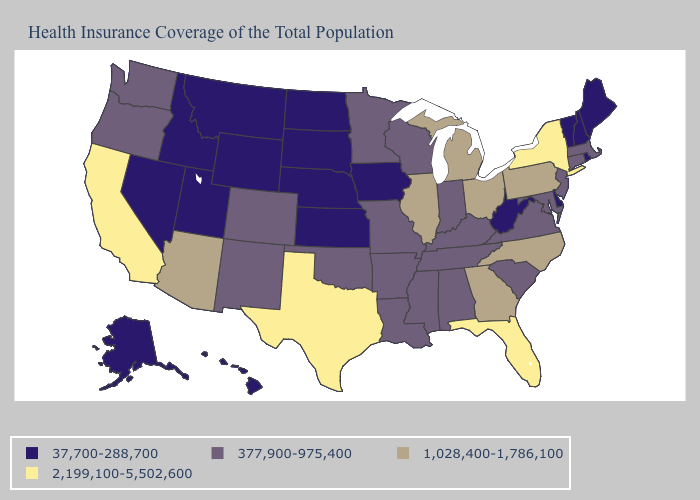Name the states that have a value in the range 2,199,100-5,502,600?
Write a very short answer. California, Florida, New York, Texas. Among the states that border West Virginia , does Pennsylvania have the highest value?
Short answer required. Yes. What is the value of Ohio?
Be succinct. 1,028,400-1,786,100. What is the highest value in the South ?
Write a very short answer. 2,199,100-5,502,600. Name the states that have a value in the range 37,700-288,700?
Quick response, please. Alaska, Delaware, Hawaii, Idaho, Iowa, Kansas, Maine, Montana, Nebraska, Nevada, New Hampshire, North Dakota, Rhode Island, South Dakota, Utah, Vermont, West Virginia, Wyoming. Does the map have missing data?
Be succinct. No. Name the states that have a value in the range 1,028,400-1,786,100?
Short answer required. Arizona, Georgia, Illinois, Michigan, North Carolina, Ohio, Pennsylvania. Which states have the lowest value in the South?
Short answer required. Delaware, West Virginia. Name the states that have a value in the range 37,700-288,700?
Be succinct. Alaska, Delaware, Hawaii, Idaho, Iowa, Kansas, Maine, Montana, Nebraska, Nevada, New Hampshire, North Dakota, Rhode Island, South Dakota, Utah, Vermont, West Virginia, Wyoming. Does Vermont have the same value as Idaho?
Quick response, please. Yes. Does the map have missing data?
Quick response, please. No. Among the states that border North Dakota , which have the highest value?
Short answer required. Minnesota. What is the lowest value in the West?
Short answer required. 37,700-288,700. Does Delaware have a higher value than Oklahoma?
Be succinct. No. Name the states that have a value in the range 1,028,400-1,786,100?
Keep it brief. Arizona, Georgia, Illinois, Michigan, North Carolina, Ohio, Pennsylvania. 